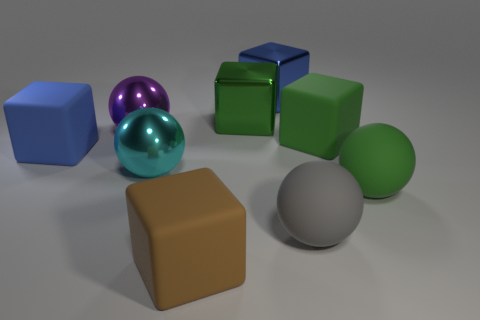Subtract all brown cubes. How many cubes are left? 4 Subtract all big green rubber cubes. How many cubes are left? 4 Subtract all cyan cubes. Subtract all green cylinders. How many cubes are left? 5 Add 1 large gray objects. How many objects exist? 10 Subtract all cubes. How many objects are left? 4 Subtract 1 cyan balls. How many objects are left? 8 Subtract all large gray matte blocks. Subtract all big purple balls. How many objects are left? 8 Add 8 cyan metal spheres. How many cyan metal spheres are left? 9 Add 5 purple shiny objects. How many purple shiny objects exist? 6 